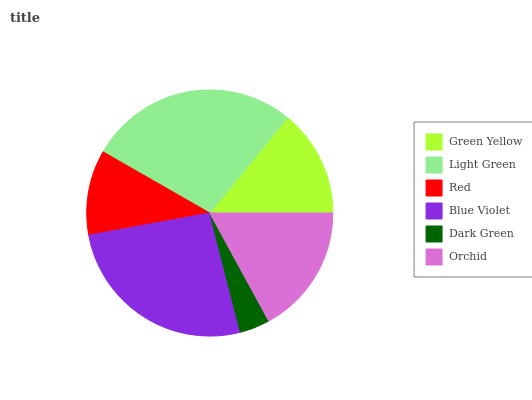Is Dark Green the minimum?
Answer yes or no. Yes. Is Light Green the maximum?
Answer yes or no. Yes. Is Red the minimum?
Answer yes or no. No. Is Red the maximum?
Answer yes or no. No. Is Light Green greater than Red?
Answer yes or no. Yes. Is Red less than Light Green?
Answer yes or no. Yes. Is Red greater than Light Green?
Answer yes or no. No. Is Light Green less than Red?
Answer yes or no. No. Is Orchid the high median?
Answer yes or no. Yes. Is Green Yellow the low median?
Answer yes or no. Yes. Is Green Yellow the high median?
Answer yes or no. No. Is Red the low median?
Answer yes or no. No. 